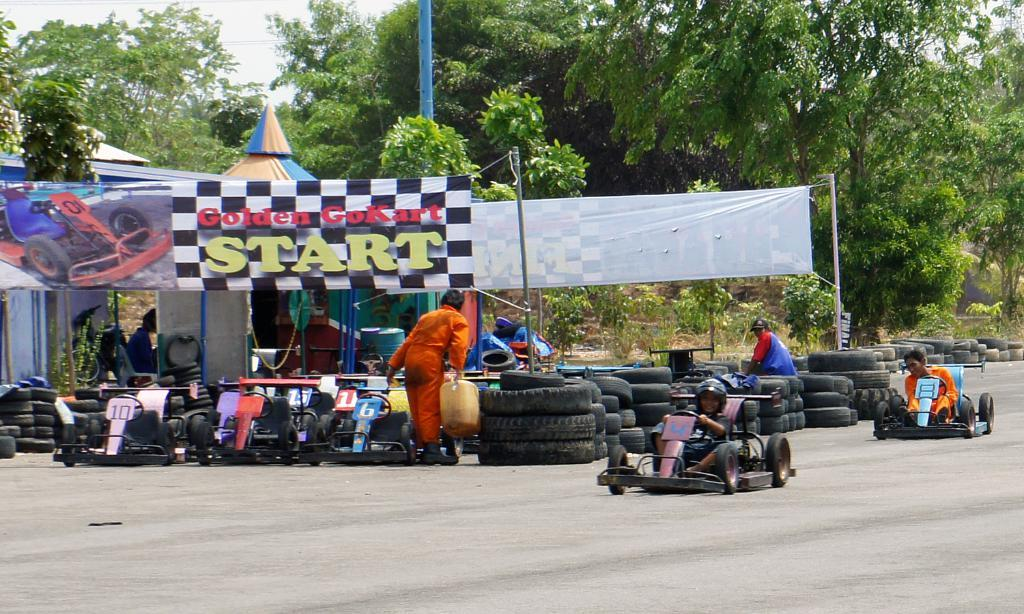What are the two persons in the image doing? The two persons are sitting and riding a vehicle. How is one person sitting on the vehicle? One person is sitting on a tire. What is the person standing holding in the image? The person standing is holding a can. What type of objects can be seen in the image related to the vehicle? There are tyres visible in the image. What else can be seen in the image related to vehicles? There are vehicles in the image. What type of natural elements can be seen in the image? Trees are present in the image. What part of the environment is visible in the image? The sky is visible in the image. What additional objects can be seen in the image? There are banners in the image. What type of whip is being used to control the vehicle in the image? There is no whip present in the image; the vehicle appears to be a stationary one. What color is the silver object on the ground in the image? There is no silver object present in the image. 